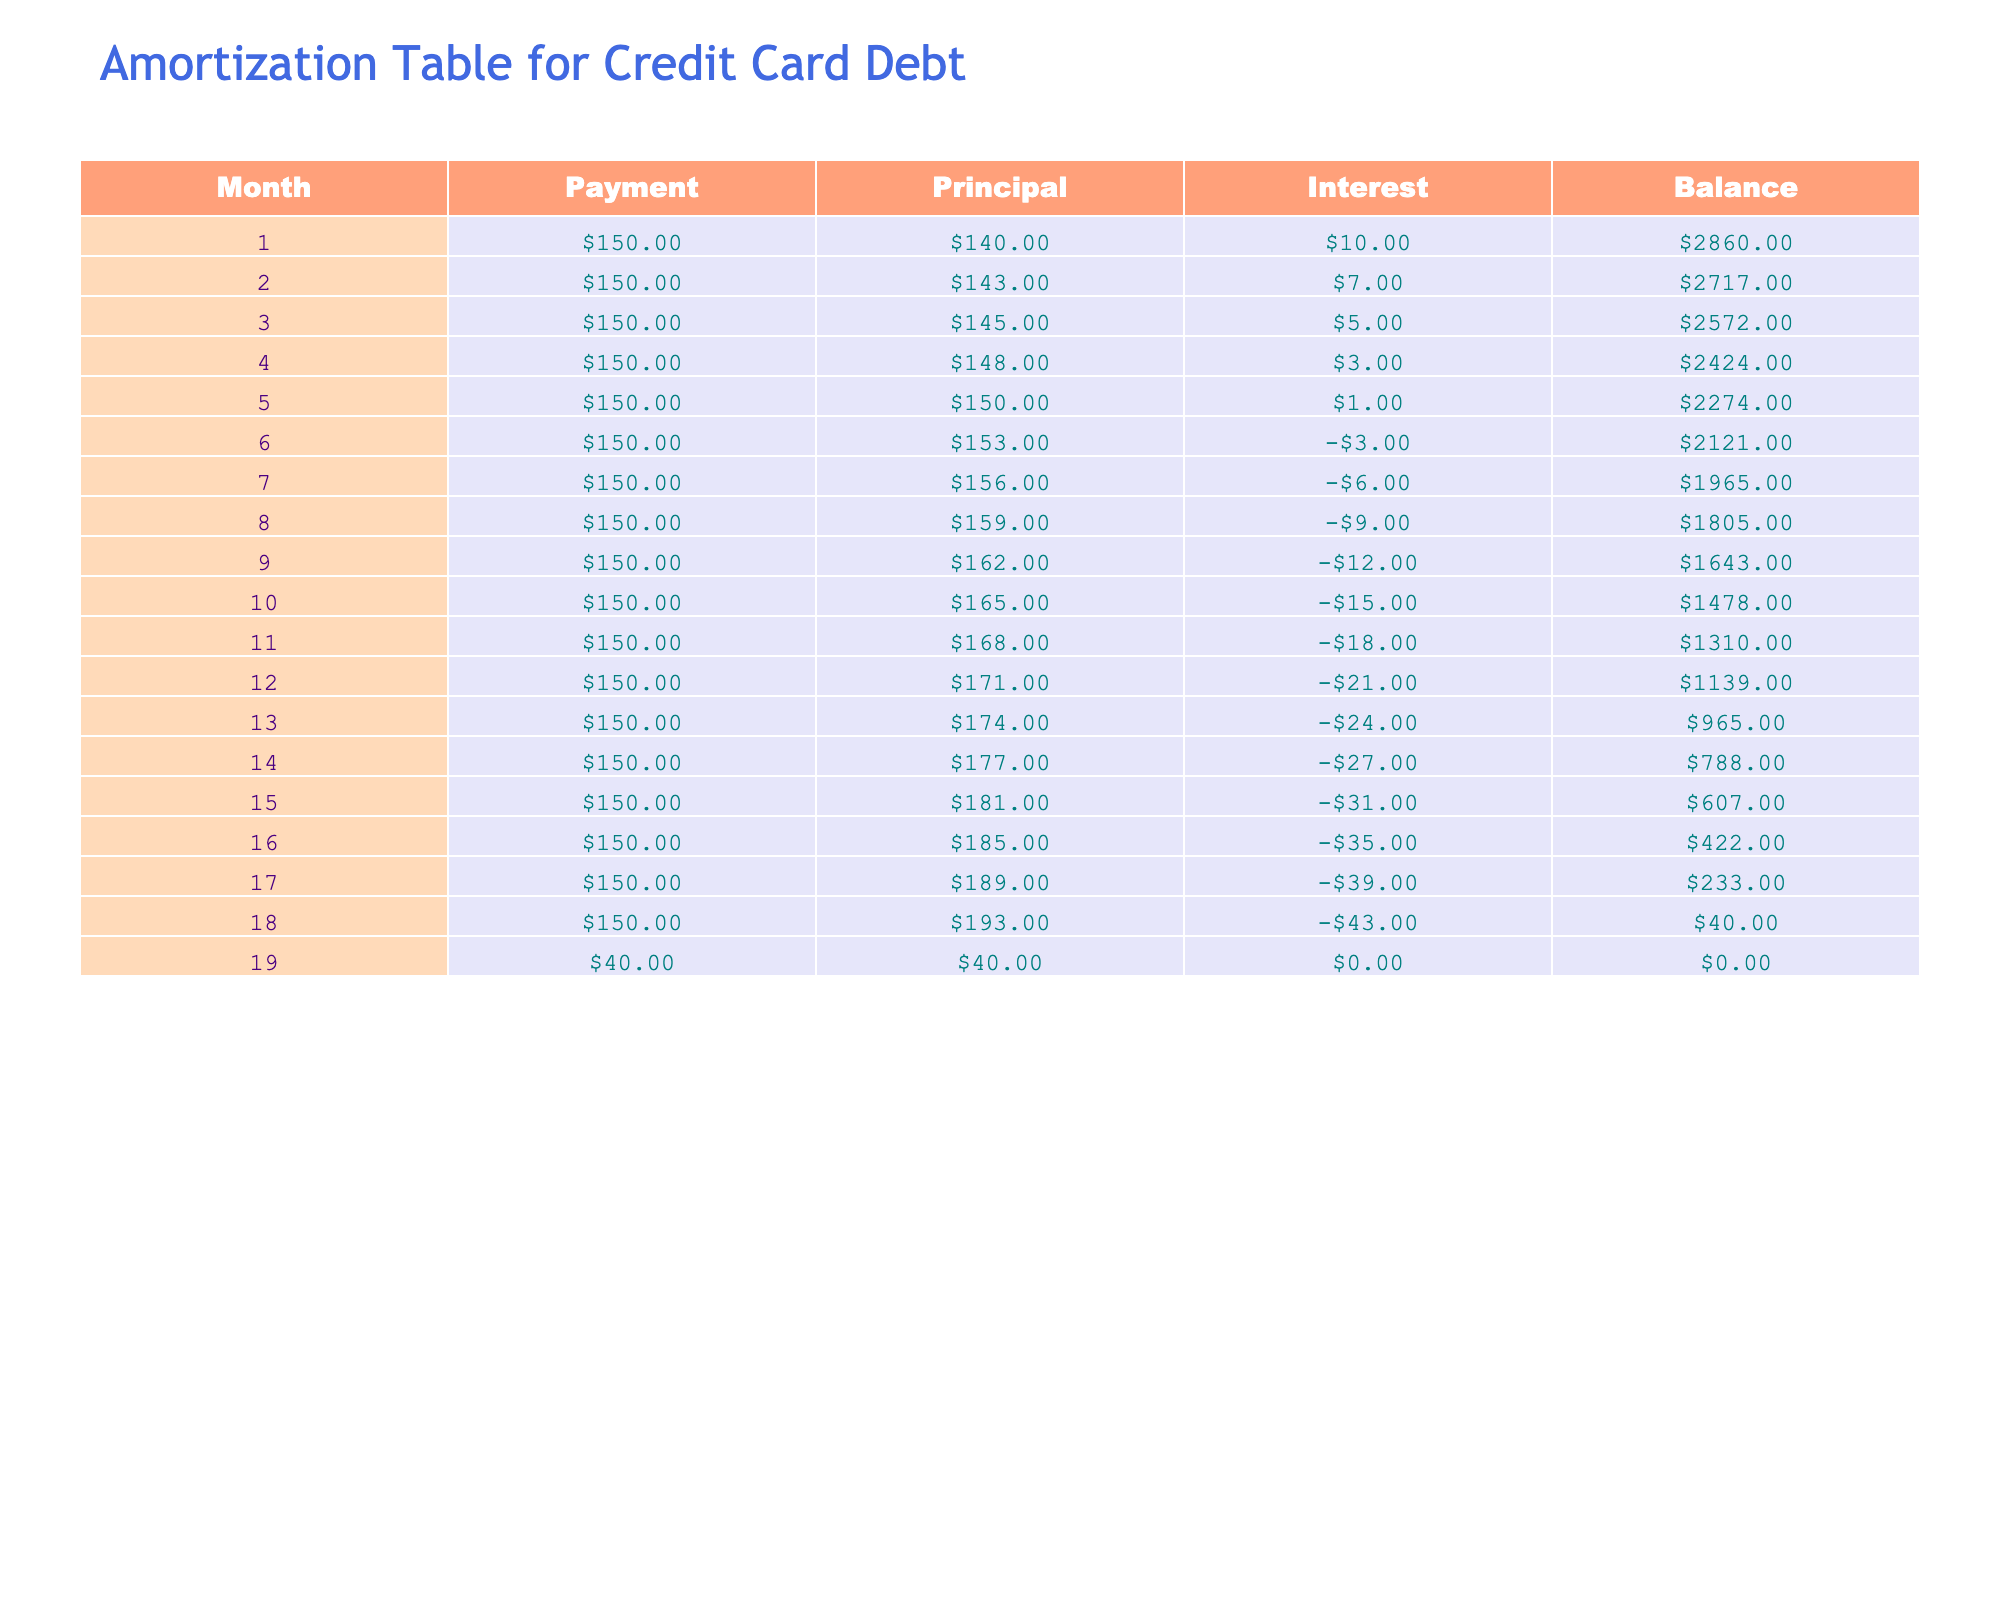What was the total payment made in the first three months? The payments made in the first three months are $150 in month 1, $150 in month 2, and $150 in month 3. Adding these amounts gives: 150 + 150 + 150 = 450.
Answer: 450 How much interest was paid in month 5? In month 5, the interest payment is shown as $1.
Answer: 1 Was there a month where the principal payment was equal to the interest payment? Looking through the table, in month 3, the principal payment is $145 and the interest payment is $5, while in month 5, the principal is $150 and interest is $1. Since there are no rows where these two amounts are the same, the answer is no.
Answer: No What is the cumulative total of the principal paid over the first six months? The principal amounts for the first six months are: $140 (month 1), $143 (month 2), $145 (month 3), $148 (month 4), $150 (month 5), and $153 (month 6). Adding these gives: 140 + 143 + 145 + 148 + 150 + 153 = 879.
Answer: 879 How did the balance change from month 1 to month 12? The balance was $2860 in month 1 and decreased to $1139 in month 12. To find the change, we can subtract the final balance from the initial balance: 2860 - 1139 = 1721. The balance decreased by $1721 over the year.
Answer: 1721 In which month did the total payment drop below $150? In month 19, the total payment is $40, dropping below the $150 previously paid in prior months.
Answer: Month 19 What was the average interest paid over the first 12 months? The interest payments over the first 12 months are: $10 (month 1), $7 (month 2), $5 (month 3), $3 (month 4), $1 (month 5), -$3 (month 6), -$6 (month 7), -$9 (month 8), -$12 (month 9), -$15 (month 10), -$18 (month 11), and -$21 (month 12). Adding these gives: 10 + 7 + 5 + 3 + 1 - 3 - 6 - 9 - 12 - 15 - 18 - 21 = -78. Since there are 12 months, the average is -78 / 12 = -6.5.
Answer: -6.5 Was the total principal repaid more than $1800 by the end of the amortization table? The total principal paid can be calculated from the individual principal amounts for the full term. When we add the principal payments from all months (1 through 19), the total is 140 + 143 + 145 + 148 + 150 + 153 + 156 + 159 + 162 + 165 + 168 + 171 + 174 + 177 + 181 + 185 + 189 + 193 + 40 = 2398. Since 2398 is greater than 1800, the answer is yes.
Answer: Yes What was the balance after the final payment in month 19? After the final payment in month 19, the balance is shown as $0.
Answer: 0 